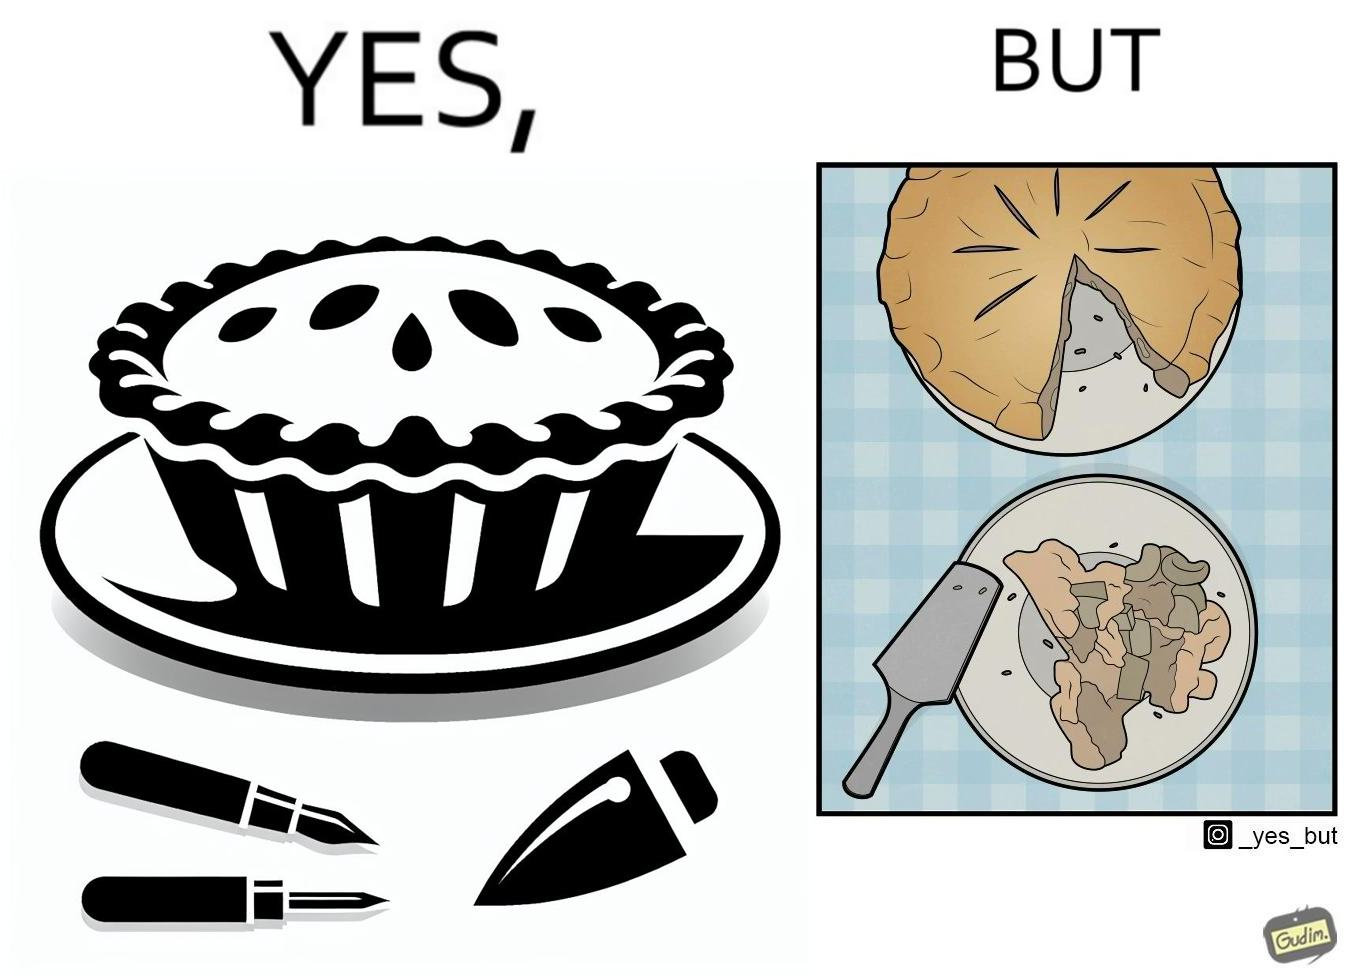What is shown in the left half versus the right half of this image? In the left part of the image: The image shows a complete pie on a plate. In the right part of the image: The image shows a slice of the pie on a smaller plate. The rest of the pie is on the original plate. 